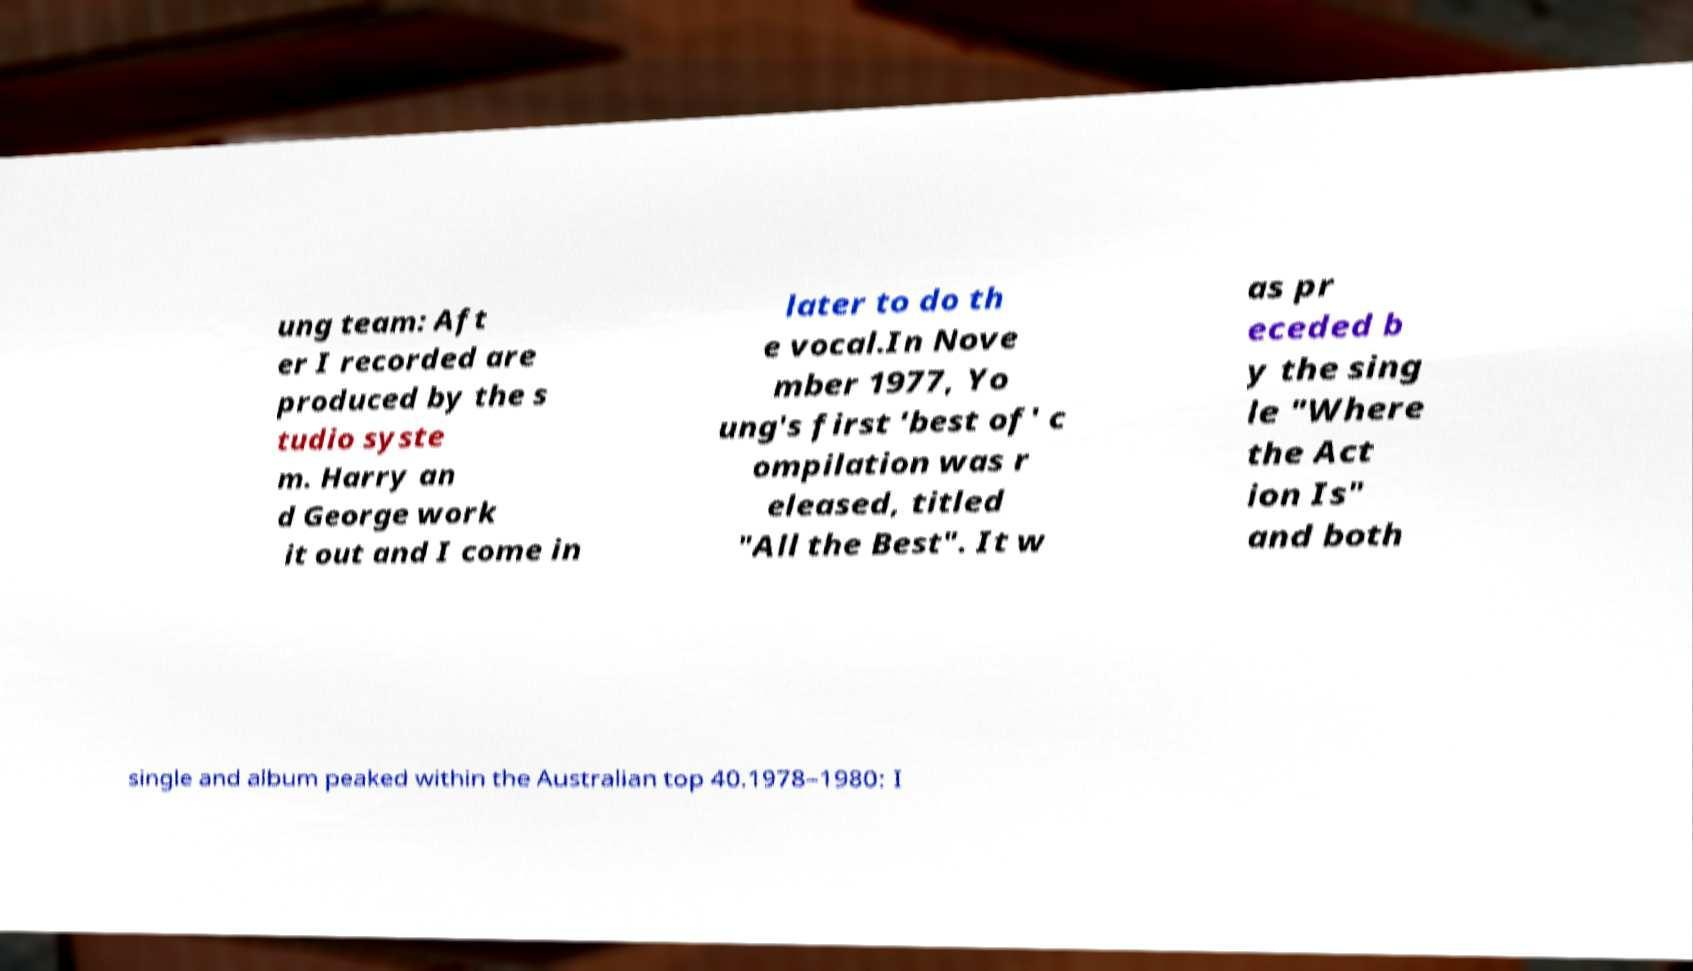I need the written content from this picture converted into text. Can you do that? ung team: Aft er I recorded are produced by the s tudio syste m. Harry an d George work it out and I come in later to do th e vocal.In Nove mber 1977, Yo ung's first 'best of' c ompilation was r eleased, titled "All the Best". It w as pr eceded b y the sing le "Where the Act ion Is" and both single and album peaked within the Australian top 40.1978–1980: I 